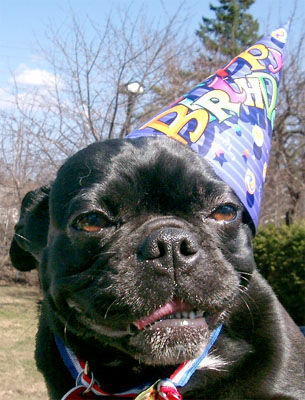Extract all visible text content from this image. P BRIHD 